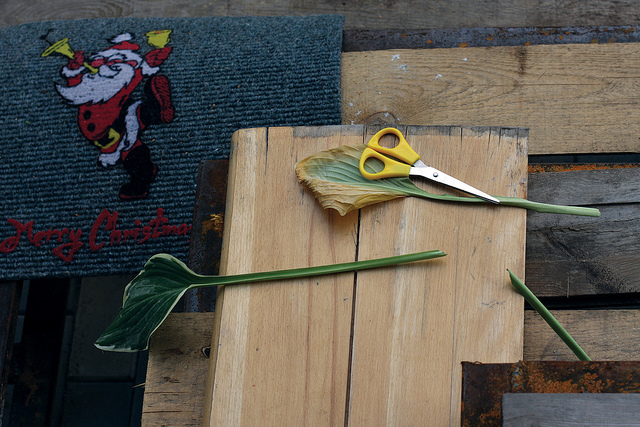Identify the text contained in this image. Christmas 